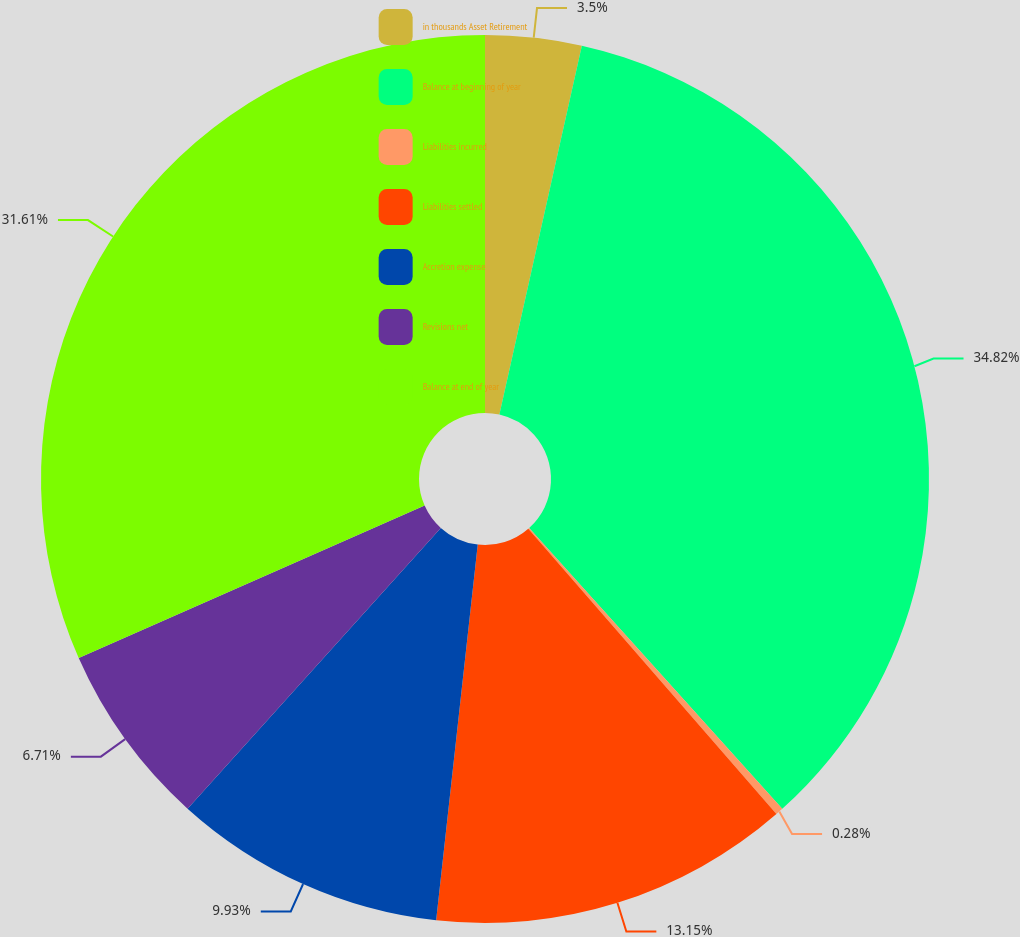Convert chart. <chart><loc_0><loc_0><loc_500><loc_500><pie_chart><fcel>in thousands Asset Retirement<fcel>Balance at beginning of year<fcel>Liabilities incurred<fcel>Liabilities settled<fcel>Accretion expense<fcel>Revisions net<fcel>Balance at end of year<nl><fcel>3.5%<fcel>34.83%<fcel>0.28%<fcel>13.15%<fcel>9.93%<fcel>6.71%<fcel>31.61%<nl></chart> 